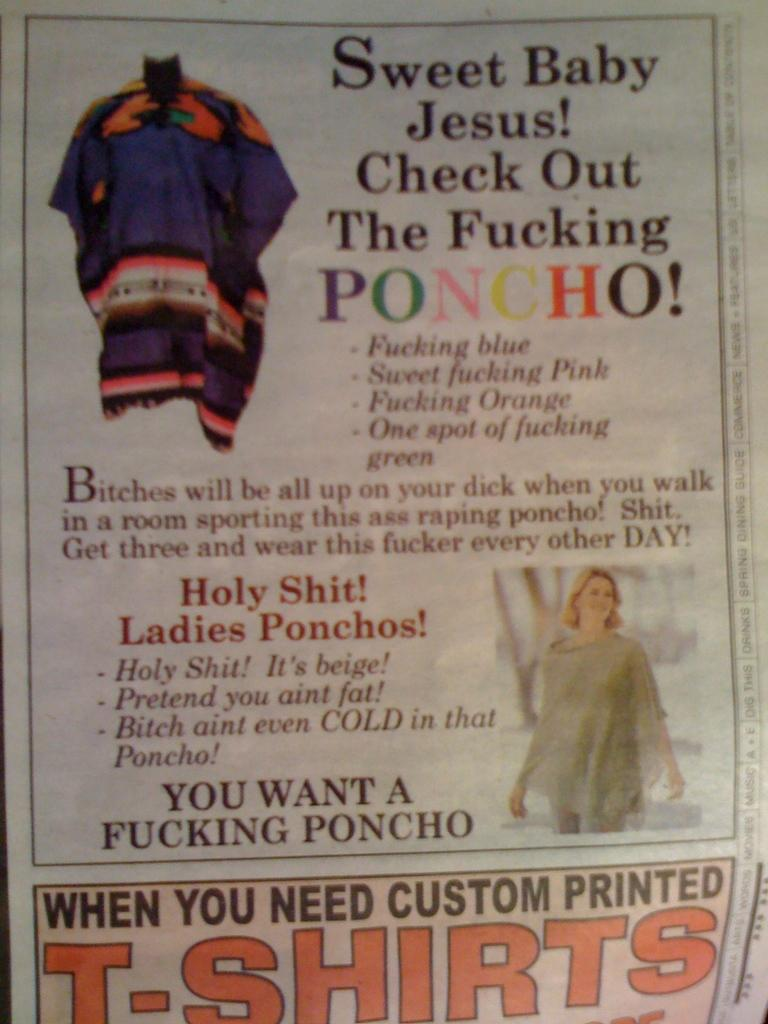What is present in the image that contains text? There is a poster in the image that contains text. What color is the background of the poster? The background of the poster is white. What type of gun is depicted on the poster in the image? There is no gun depicted on the poster in the image; it only contains text and has a white background. 